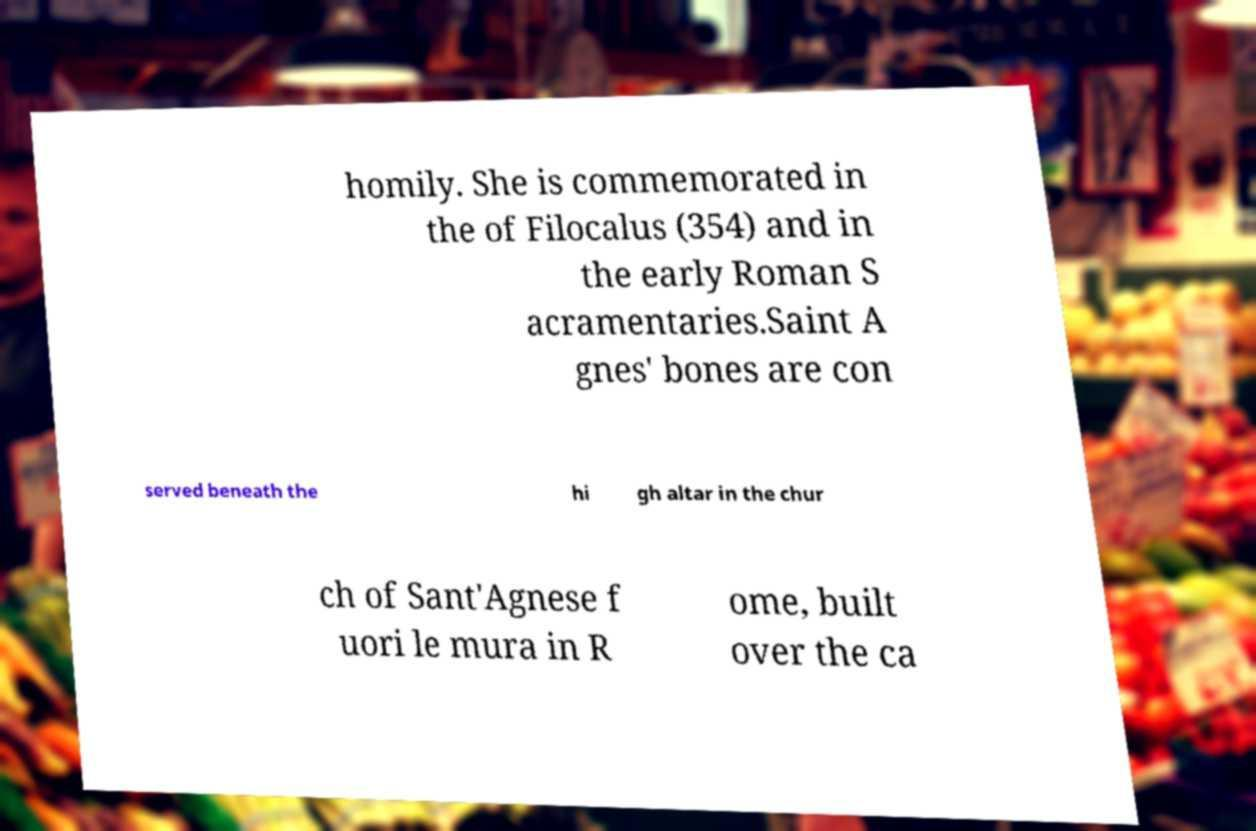Please identify and transcribe the text found in this image. homily. She is commemorated in the of Filocalus (354) and in the early Roman S acramentaries.Saint A gnes' bones are con served beneath the hi gh altar in the chur ch of Sant'Agnese f uori le mura in R ome, built over the ca 